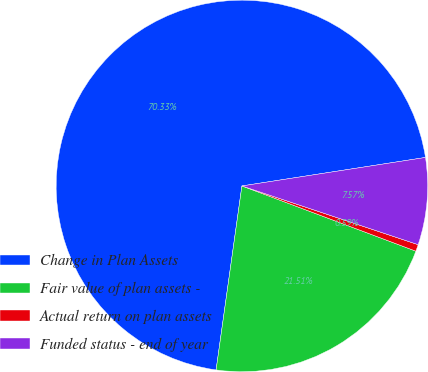Convert chart. <chart><loc_0><loc_0><loc_500><loc_500><pie_chart><fcel>Change in Plan Assets<fcel>Fair value of plan assets -<fcel>Actual return on plan assets<fcel>Funded status - end of year<nl><fcel>70.33%<fcel>21.51%<fcel>0.59%<fcel>7.57%<nl></chart> 